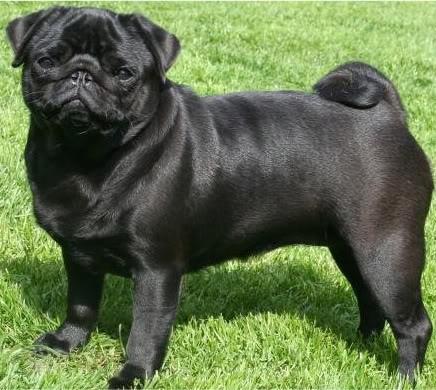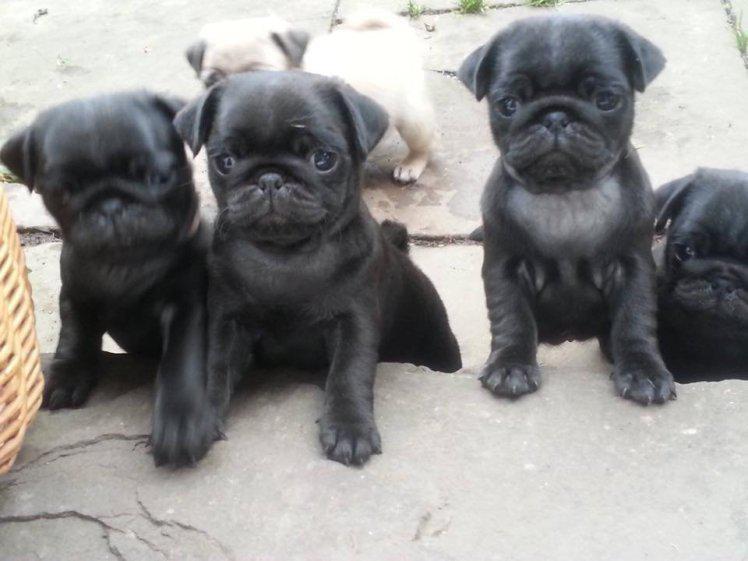The first image is the image on the left, the second image is the image on the right. Considering the images on both sides, is "The right image contains one black pug and a human hand, and no image contains a standing dog." valid? Answer yes or no. No. The first image is the image on the left, the second image is the image on the right. Evaluate the accuracy of this statement regarding the images: "There is only one dog in each of the images.". Is it true? Answer yes or no. No. 